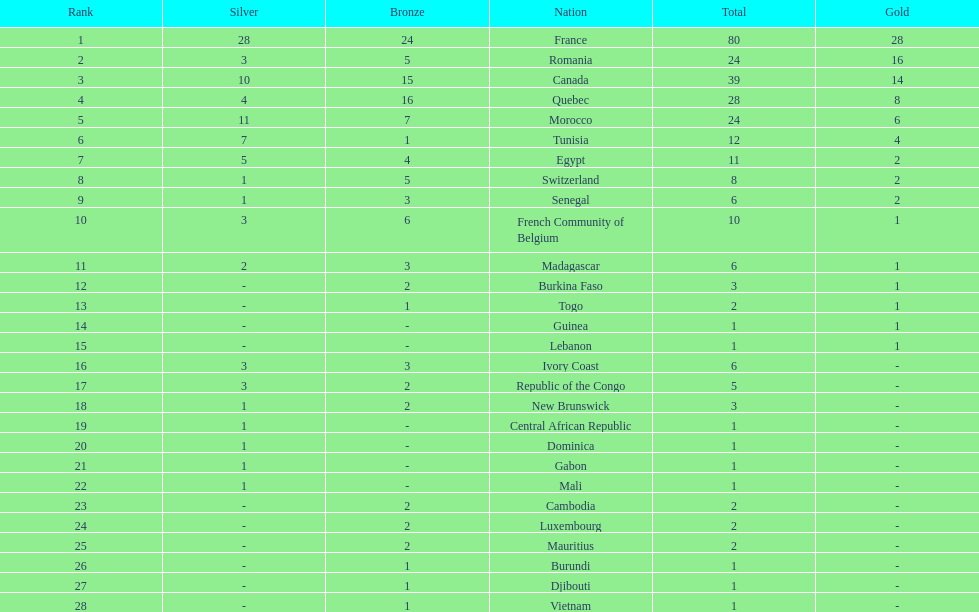How many counties have at least one silver medal? 18. Could you parse the entire table as a dict? {'header': ['Rank', 'Silver', 'Bronze', 'Nation', 'Total', 'Gold'], 'rows': [['1', '28', '24', 'France', '80', '28'], ['2', '3', '5', 'Romania', '24', '16'], ['3', '10', '15', 'Canada', '39', '14'], ['4', '4', '16', 'Quebec', '28', '8'], ['5', '11', '7', 'Morocco', '24', '6'], ['6', '7', '1', 'Tunisia', '12', '4'], ['7', '5', '4', 'Egypt', '11', '2'], ['8', '1', '5', 'Switzerland', '8', '2'], ['9', '1', '3', 'Senegal', '6', '2'], ['10', '3', '6', 'French Community of Belgium', '10', '1'], ['11', '2', '3', 'Madagascar', '6', '1'], ['12', '-', '2', 'Burkina Faso', '3', '1'], ['13', '-', '1', 'Togo', '2', '1'], ['14', '-', '-', 'Guinea', '1', '1'], ['15', '-', '-', 'Lebanon', '1', '1'], ['16', '3', '3', 'Ivory Coast', '6', '-'], ['17', '3', '2', 'Republic of the Congo', '5', '-'], ['18', '1', '2', 'New Brunswick', '3', '-'], ['19', '1', '-', 'Central African Republic', '1', '-'], ['20', '1', '-', 'Dominica', '1', '-'], ['21', '1', '-', 'Gabon', '1', '-'], ['22', '1', '-', 'Mali', '1', '-'], ['23', '-', '2', 'Cambodia', '2', '-'], ['24', '-', '2', 'Luxembourg', '2', '-'], ['25', '-', '2', 'Mauritius', '2', '-'], ['26', '-', '1', 'Burundi', '1', '-'], ['27', '-', '1', 'Djibouti', '1', '-'], ['28', '-', '1', 'Vietnam', '1', '-']]} 